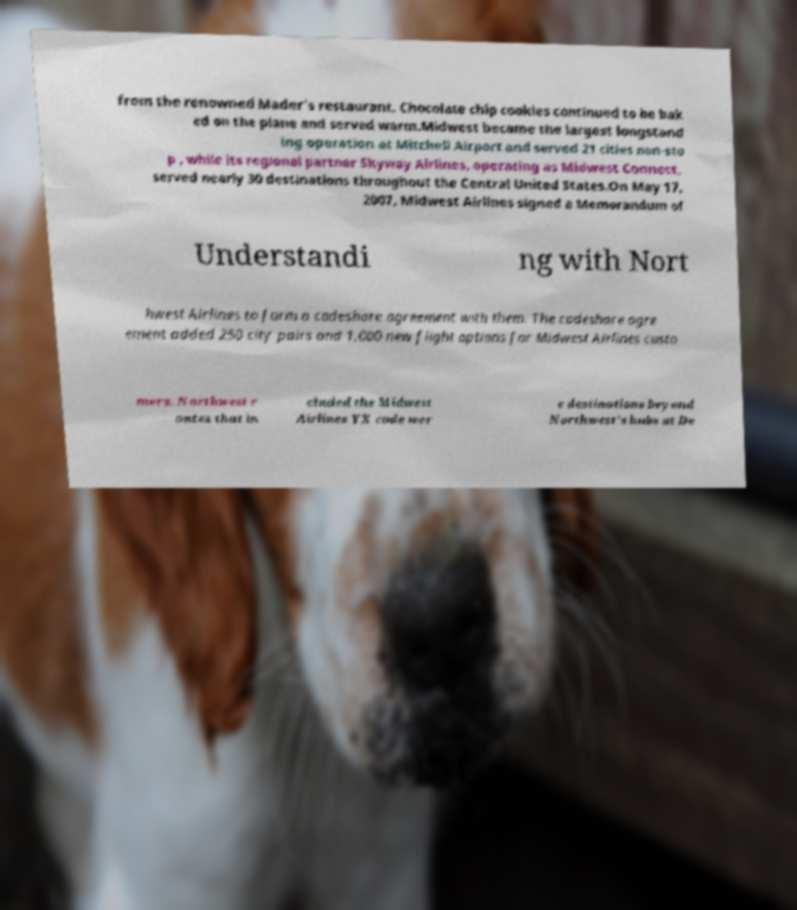Please identify and transcribe the text found in this image. from the renowned Mader's restaurant. Chocolate chip cookies continued to be bak ed on the plane and served warm.Midwest became the largest longstand ing operation at Mitchell Airport and served 21 cities non-sto p , while its regional partner Skyway Airlines, operating as Midwest Connect, served nearly 30 destinations throughout the Central United States.On May 17, 2007, Midwest Airlines signed a Memorandum of Understandi ng with Nort hwest Airlines to form a codeshare agreement with them. The codeshare agre ement added 250 city pairs and 1,000 new flight options for Midwest Airlines custo mers. Northwest r outes that in cluded the Midwest Airlines YX code wer e destinations beyond Northwest's hubs at De 